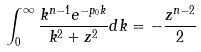Convert formula to latex. <formula><loc_0><loc_0><loc_500><loc_500>\int _ { 0 } ^ { \infty } \frac { k ^ { n - 1 } e ^ { - p _ { 0 } k } } { k ^ { 2 } + z ^ { 2 } } d k = - \frac { z ^ { n - 2 } } { 2 }</formula> 